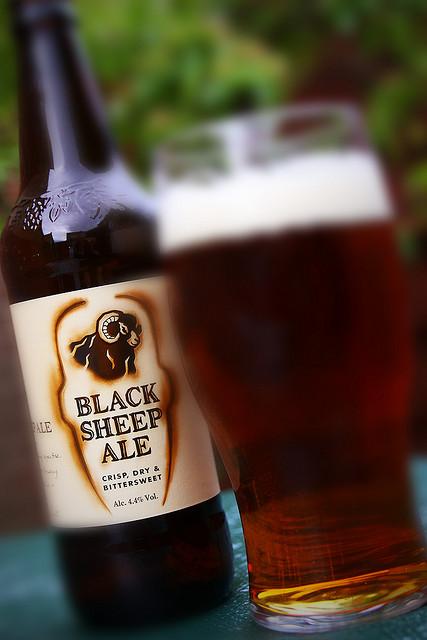Would this be a good beverage for a child?
Write a very short answer. No. Is this root beer?
Write a very short answer. No. Is this an alcoholic beverage?
Be succinct. Yes. 